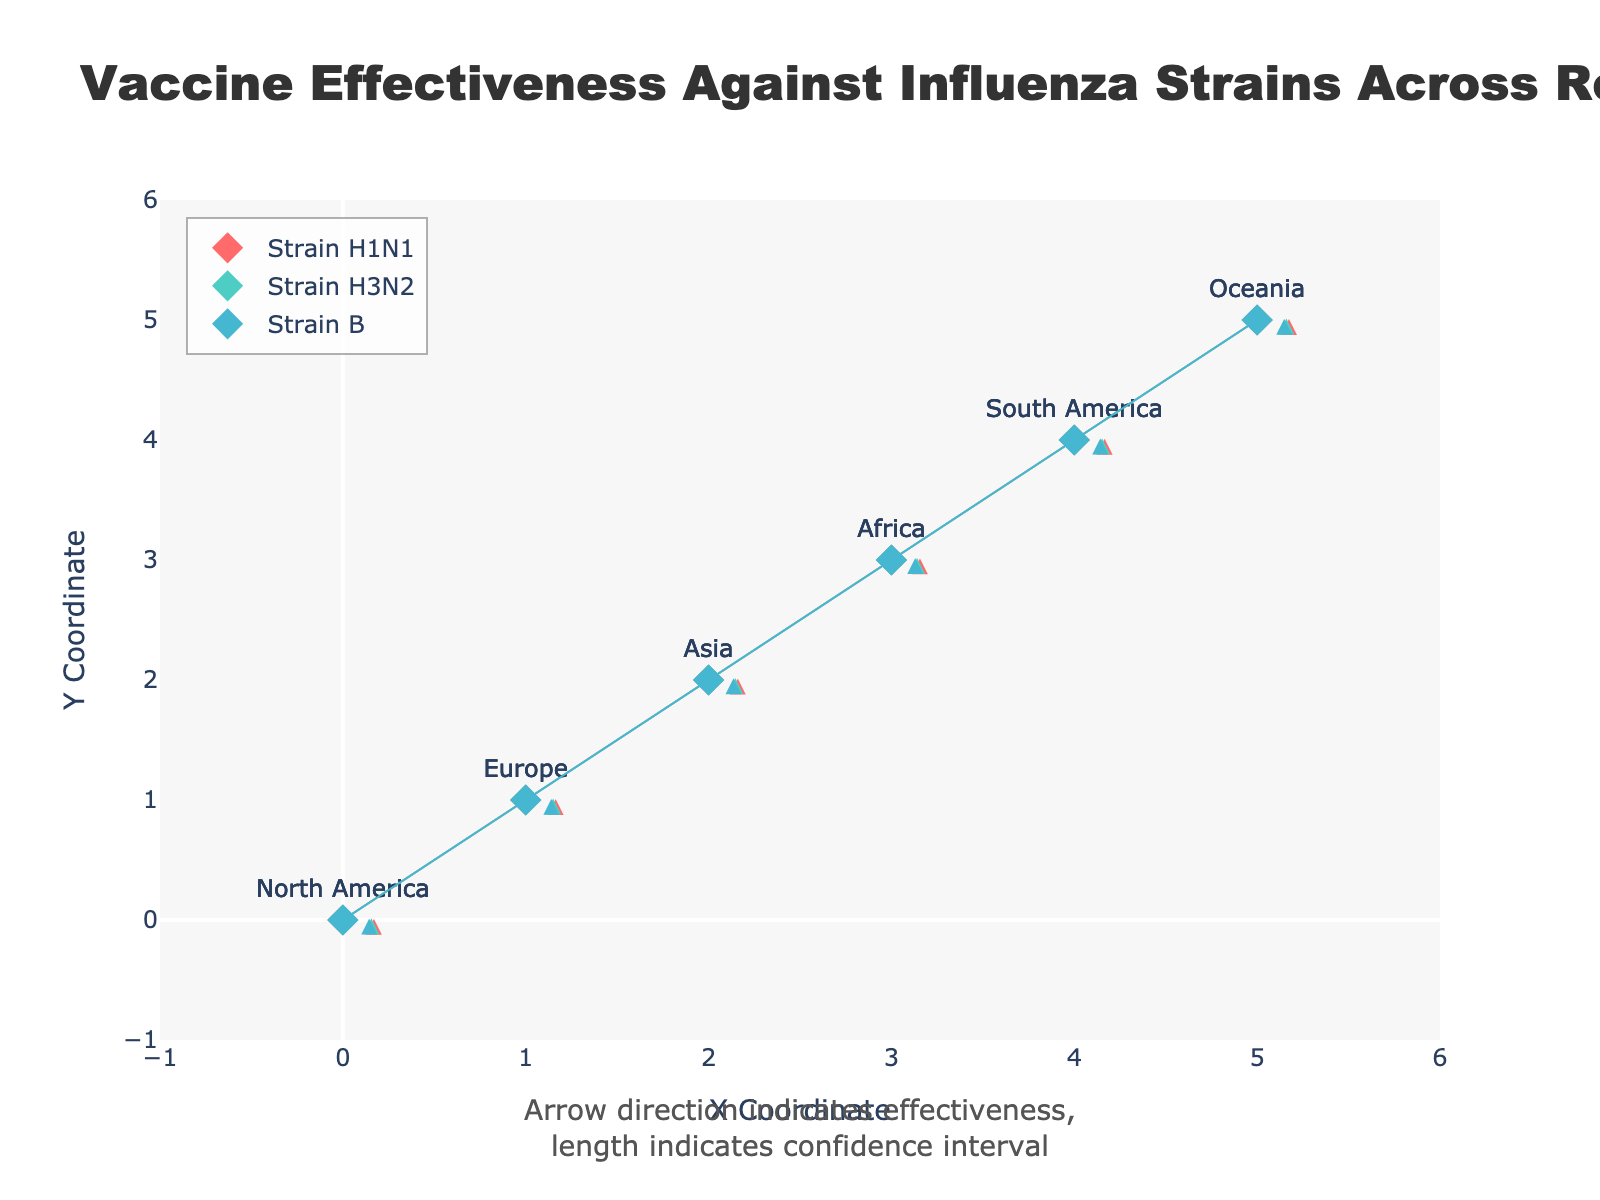What is the title of the plot? The title is located at the top of the plot in a larger and bolder font compared to other text.
Answer: Vaccine Effectiveness Against Influenza Strains Across Regions How many regions are represented in the plot? By counting the distinct points and labels placed on the figure for different regions, we can determine the total number. There are six regions labeled: North America, Europe, Asia, Africa, South America, and Oceania.
Answer: 6 Which strain shows the longest arrow in North America, indicating the highest confidence interval? We look at the North America point (0,0) and compare the lengths of the arrows for H1N1, H3N2, and B strains. The arrow with the longest length represents the highest confidence interval for that strain. By observing, U and V components of H1N1 (0.85, 0.05) have a higher value compared to H3N2 and B.
Answer: H1N1 What region shows the smallest effectiveness value for strain B? By observing the lengths of the B strain arrows across regions, the lengths can be inferred from their end coordinates. The shortest arrow indicates the smallest effectiveness value. Africa’s arrow for strain B seems to be the shortest, indicating lower effectiveness.
Answer: Africa Compare the effectiveness of the H3N2 strain between Europe and Asia, and determine which region has higher effectiveness. To compare, look at the vectors for H3N2 strain in Europe and Asia (coordinates 1,1 and 2,2). The effectiveness is represented by the length of the arrow. Here, Europe (U:0.75, V:0.06) slightly has higher effectiveness compared to Asia (U:0.73, V:0.08).
Answer: Europe Which strain shows the highest overall effectiveness in Oceania? Oceania is at point (5,5). By comparing the arrows for all three strains in Oceania, the strain with the longest arrow indicates the highest effectiveness. H1N1 (U:0.87, V:0.04) appears to have the highest effectiveness compared to H3N2 and B.
Answer: H1N1 How does the effectiveness of strain H1N1 in South America compare to that in Africa? The effectiveness is represented by the arrow length. By comparing the H1N1 arrows at points for South America (4,4; U:0.83, V:0.05) and Africa (3,3; U:0.78, V:0.07), South America has a higher effectiveness.
Answer: South America Calculate the average effectiveness value for strain B across all regions. Calculate the average by summing all the U values for strain B across regions, then dividing by the number of regions. The values are 0.72, 0.70, 0.68, 0.65, 0.71, 0.74 summing to 4.2. The average is 4.2 / 6 = 0.70.
Answer: 0.70 What is the direction of the confidence interval for strain H3N2 in Asia? The direction of the confidence interval for arrows can be determined by looking at the V component. For H3N2 in Asia, point (2,2), the vector is (U:0.73, V:0.08), indicating a slight upward direction.
Answer: Slightly upward Which region has the smallest overall confidence interval for all strains and how did you determine it? To measure smallest overall confidence interval, compare the sum of V components for all strains in each region. The smallest sum indicates the least variability. North America has the smallest total confidence interval (0.05 + 0.07 + 0.06 = 0.18).
Answer: North America 